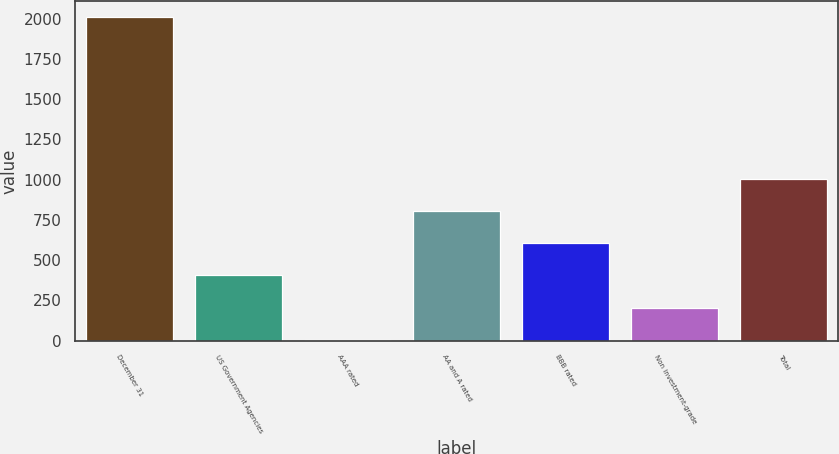<chart> <loc_0><loc_0><loc_500><loc_500><bar_chart><fcel>December 31<fcel>US Government Agencies<fcel>AAA rated<fcel>AA and A rated<fcel>BBB rated<fcel>Non investment-grade<fcel>Total<nl><fcel>2009<fcel>405.4<fcel>4.5<fcel>806.3<fcel>605.85<fcel>204.95<fcel>1006.75<nl></chart> 